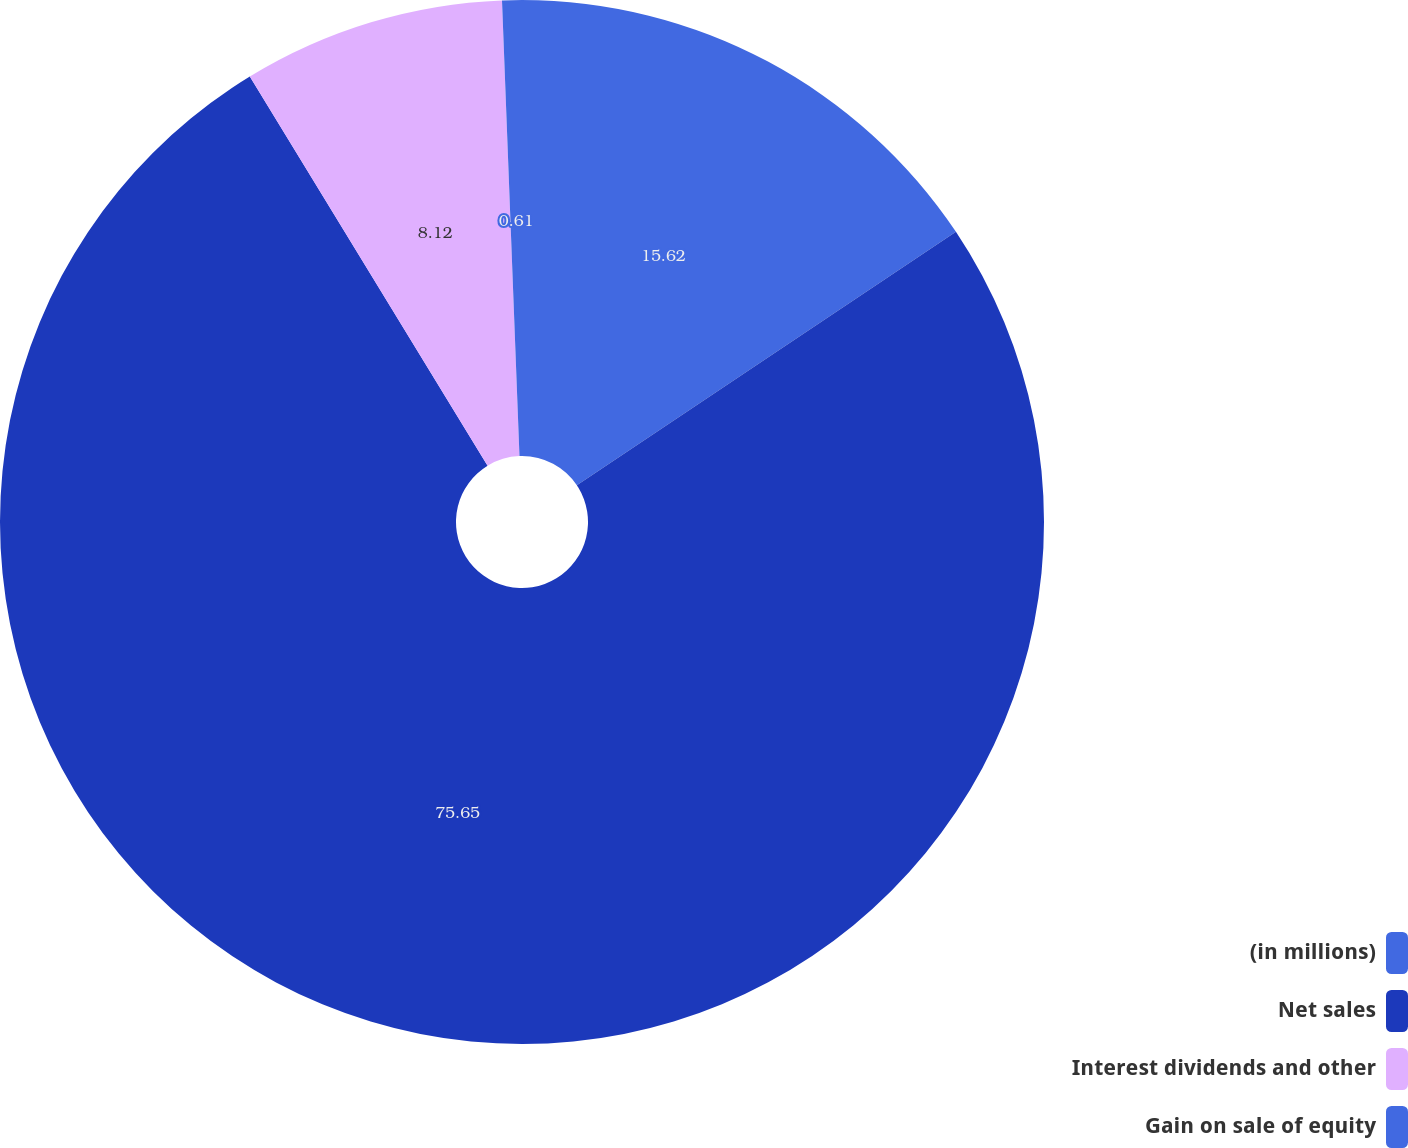Convert chart. <chart><loc_0><loc_0><loc_500><loc_500><pie_chart><fcel>(in millions)<fcel>Net sales<fcel>Interest dividends and other<fcel>Gain on sale of equity<nl><fcel>15.62%<fcel>75.65%<fcel>8.12%<fcel>0.61%<nl></chart> 